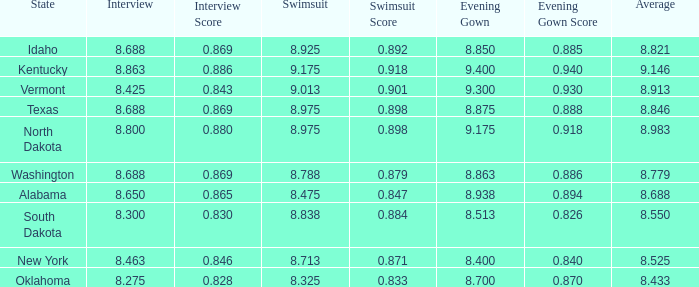What is the lowest average of the contestant with an interview of 8.275 and an evening gown bigger than 8.7? None. 